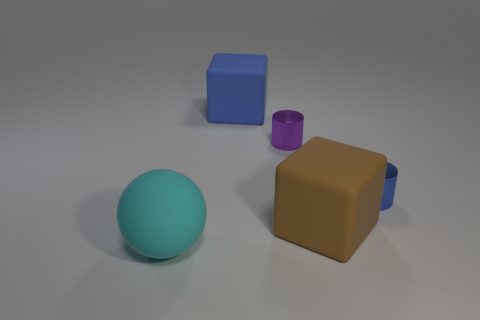There is a thing that is both to the left of the small purple metal object and in front of the blue block; what is its size?
Give a very brief answer. Large. How many matte objects are purple blocks or large blue things?
Make the answer very short. 1. What material is the cyan ball?
Your answer should be very brief. Rubber. What is the material of the blue thing that is right of the big brown rubber object in front of the large rubber cube that is on the left side of the small purple metallic cylinder?
Provide a short and direct response. Metal. What is the shape of the brown thing that is the same size as the matte sphere?
Provide a short and direct response. Cube. How many things are either cyan balls or matte objects that are on the right side of the large matte sphere?
Your response must be concise. 3. Is the blue object in front of the blue cube made of the same material as the block that is left of the large brown rubber thing?
Your answer should be very brief. No. What number of blue things are rubber things or large rubber spheres?
Make the answer very short. 1. What size is the purple metallic cylinder?
Offer a terse response. Small. Are there more tiny metallic cylinders that are behind the tiny blue metallic cylinder than small purple shiny things?
Your answer should be very brief. No. 